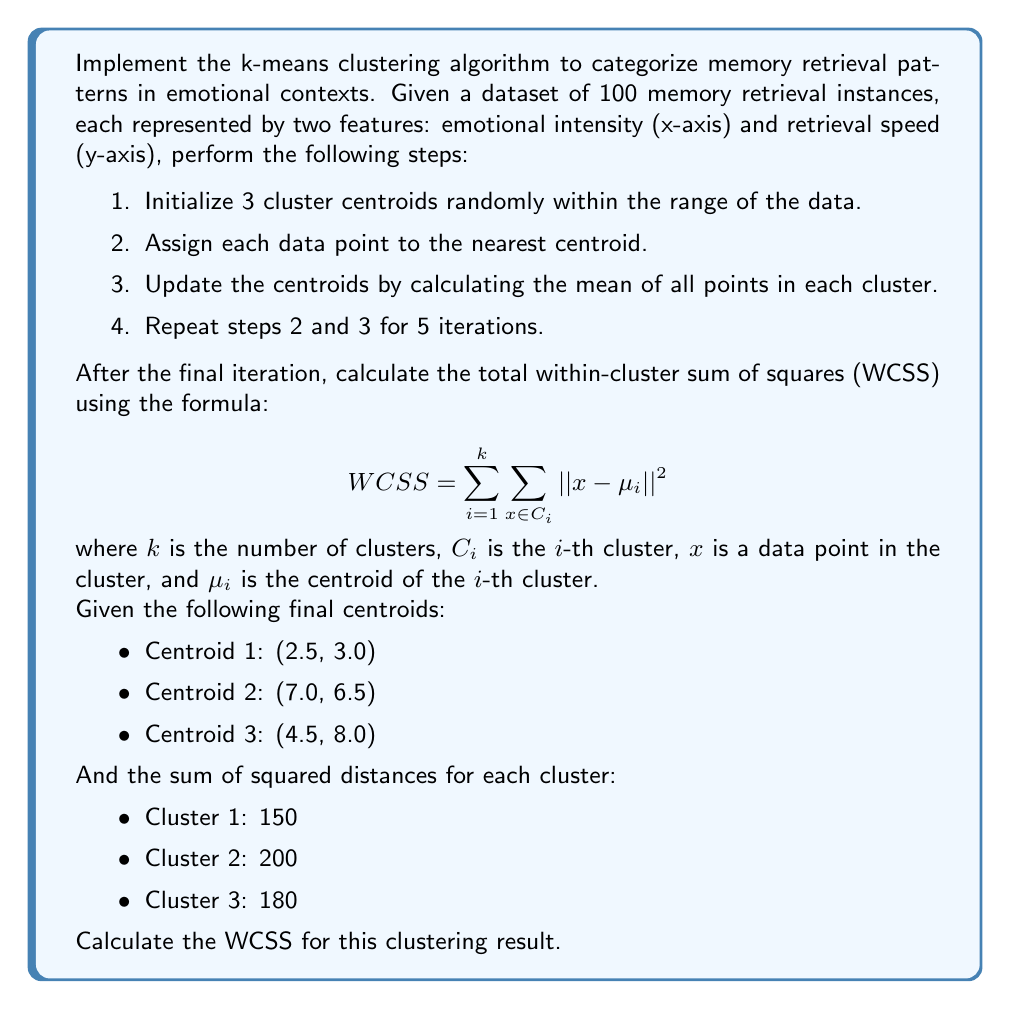Teach me how to tackle this problem. To solve this problem, we need to understand the concept of Within-Cluster Sum of Squares (WCSS) and how to calculate it using the given information.

The WCSS is a measure of the compactness of the clusters. It is calculated by summing the squared distances between each data point and its assigned cluster centroid, then summing these values for all clusters.

Given:
- We have 3 clusters (k = 3)
- The sum of squared distances for each cluster is provided

Step 1: Recall the WCSS formula
$$ WCSS = \sum_{i=1}^{k} \sum_{x \in C_i} ||x - \mu_i||^2 $$

Step 2: Understand what the given sums represent
The sum of squared distances for each cluster is equivalent to $\sum_{x \in C_i} ||x - \mu_i||^2$ for that particular cluster.

Step 3: Sum the given values for each cluster
WCSS = (Sum for Cluster 1) + (Sum for Cluster 2) + (Sum for Cluster 3)
WCSS = 150 + 200 + 180

Step 4: Calculate the total WCSS
WCSS = 530

Therefore, the total Within-Cluster Sum of Squares (WCSS) for this clustering result is 530.
Answer: 530 